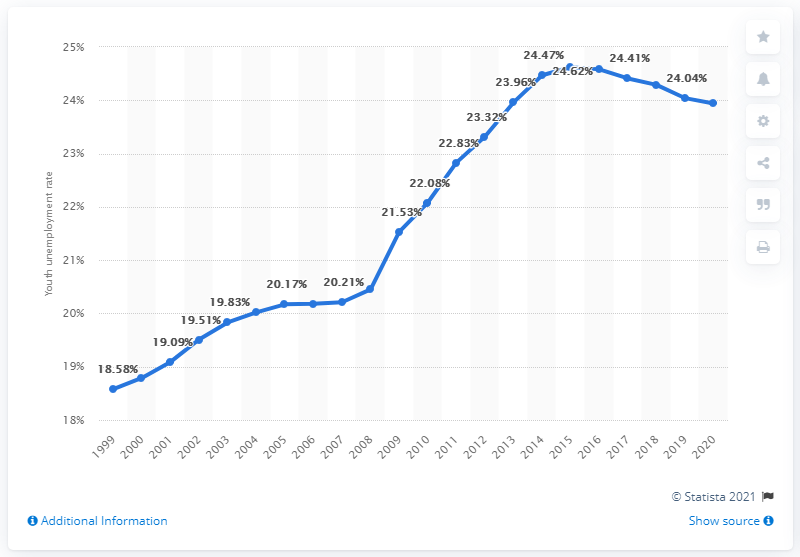Highlight a few significant elements in this photo. In 2020, the youth unemployment rate in Yemen was 23.94%. 